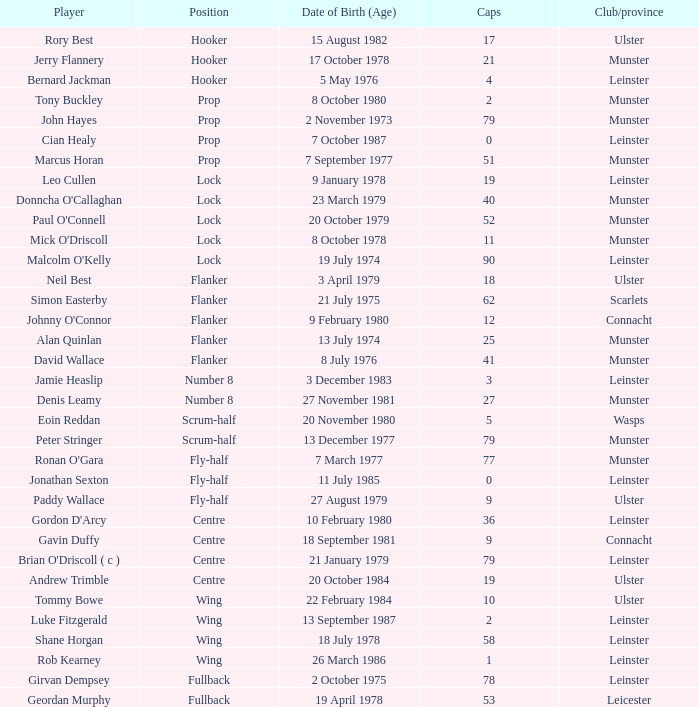How many Caps does the Club/province Munster, position of lock and Mick O'Driscoll have? 1.0. 